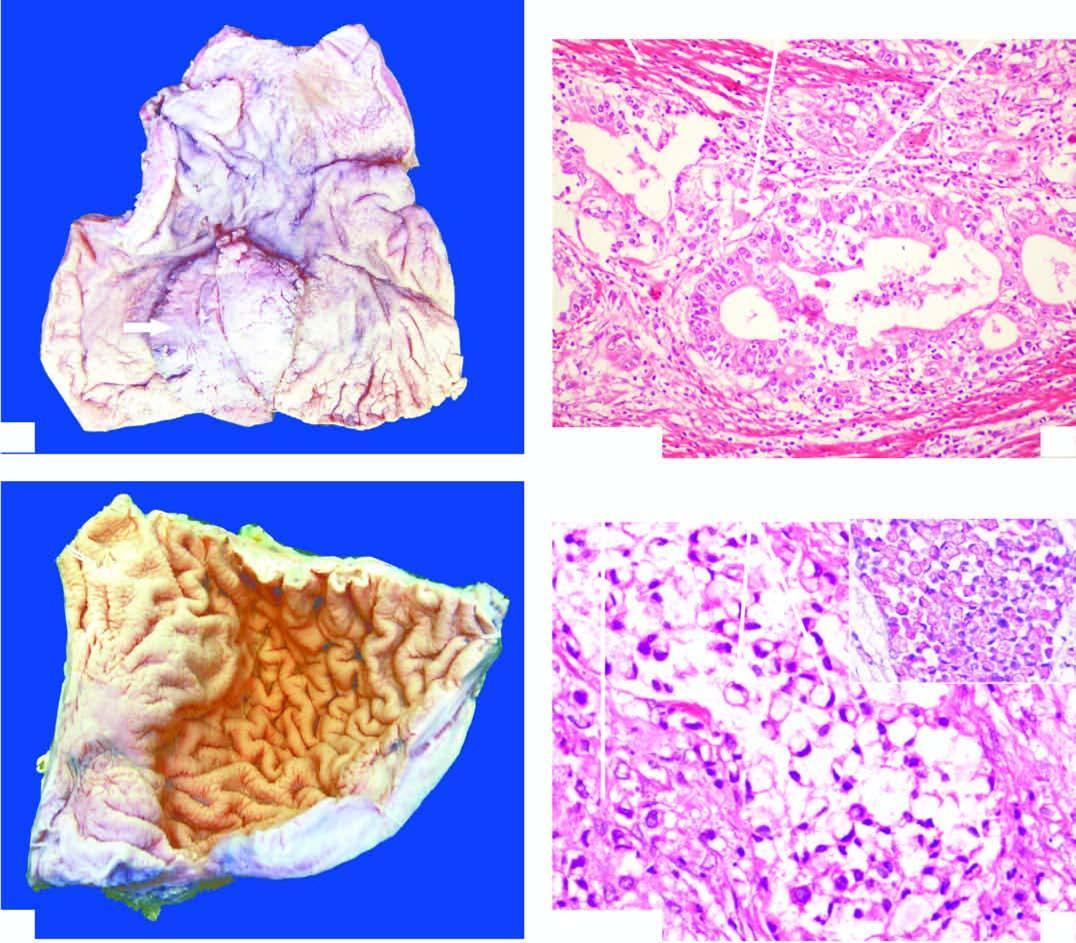re lassification of chromosomes seen invading the layers of the stomach wall?
Answer the question using a single word or phrase. No 